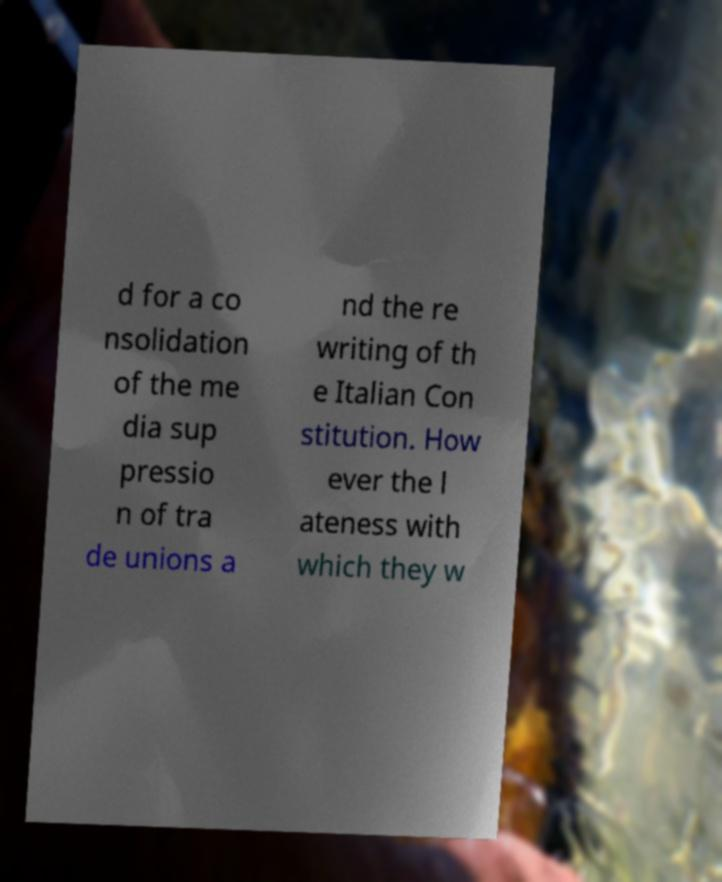There's text embedded in this image that I need extracted. Can you transcribe it verbatim? d for a co nsolidation of the me dia sup pressio n of tra de unions a nd the re writing of th e Italian Con stitution. How ever the l ateness with which they w 